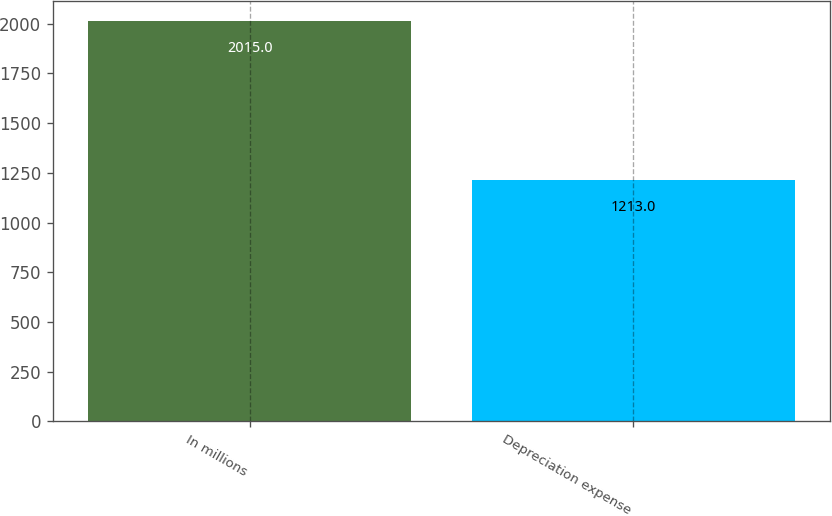Convert chart. <chart><loc_0><loc_0><loc_500><loc_500><bar_chart><fcel>In millions<fcel>Depreciation expense<nl><fcel>2015<fcel>1213<nl></chart> 